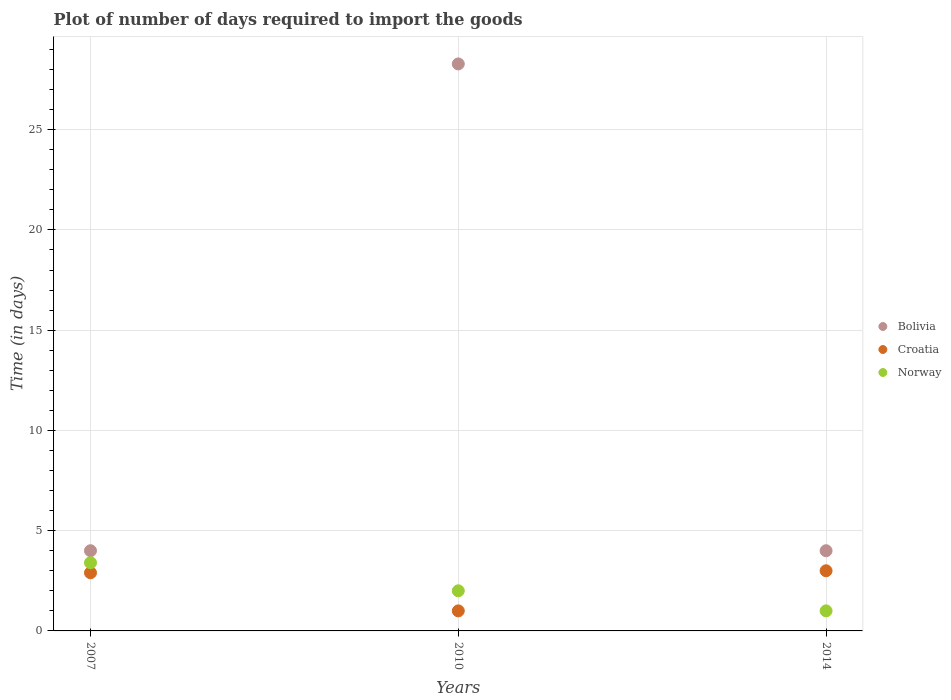How many different coloured dotlines are there?
Offer a terse response. 3. Is the number of dotlines equal to the number of legend labels?
Give a very brief answer. Yes. What is the time required to import goods in Croatia in 2007?
Give a very brief answer. 2.9. Across all years, what is the maximum time required to import goods in Bolivia?
Keep it short and to the point. 28.28. Across all years, what is the minimum time required to import goods in Norway?
Your answer should be compact. 1. What is the difference between the time required to import goods in Norway in 2010 and that in 2014?
Offer a terse response. 1. What is the average time required to import goods in Croatia per year?
Your response must be concise. 2.3. In the year 2014, what is the difference between the time required to import goods in Croatia and time required to import goods in Norway?
Your answer should be compact. 2. In how many years, is the time required to import goods in Bolivia greater than 22 days?
Your answer should be compact. 1. What is the ratio of the time required to import goods in Bolivia in 2007 to that in 2014?
Your answer should be very brief. 1. Is the difference between the time required to import goods in Croatia in 2007 and 2014 greater than the difference between the time required to import goods in Norway in 2007 and 2014?
Ensure brevity in your answer.  No. What is the difference between the highest and the second highest time required to import goods in Bolivia?
Your response must be concise. 24.28. What is the difference between the highest and the lowest time required to import goods in Bolivia?
Give a very brief answer. 24.28. Is it the case that in every year, the sum of the time required to import goods in Norway and time required to import goods in Croatia  is greater than the time required to import goods in Bolivia?
Offer a terse response. No. Does the time required to import goods in Bolivia monotonically increase over the years?
Your answer should be compact. No. Is the time required to import goods in Croatia strictly less than the time required to import goods in Norway over the years?
Offer a terse response. No. How many dotlines are there?
Your answer should be compact. 3. What is the difference between two consecutive major ticks on the Y-axis?
Offer a terse response. 5. Are the values on the major ticks of Y-axis written in scientific E-notation?
Provide a short and direct response. No. Does the graph contain any zero values?
Make the answer very short. No. Does the graph contain grids?
Your response must be concise. Yes. Where does the legend appear in the graph?
Your answer should be very brief. Center right. How are the legend labels stacked?
Your response must be concise. Vertical. What is the title of the graph?
Provide a short and direct response. Plot of number of days required to import the goods. What is the label or title of the X-axis?
Provide a succinct answer. Years. What is the label or title of the Y-axis?
Provide a short and direct response. Time (in days). What is the Time (in days) of Croatia in 2007?
Provide a succinct answer. 2.9. What is the Time (in days) of Norway in 2007?
Your answer should be compact. 3.4. What is the Time (in days) of Bolivia in 2010?
Give a very brief answer. 28.28. What is the Time (in days) of Croatia in 2010?
Offer a terse response. 1. What is the Time (in days) of Bolivia in 2014?
Offer a terse response. 4. What is the Time (in days) of Croatia in 2014?
Ensure brevity in your answer.  3. What is the Time (in days) of Norway in 2014?
Offer a very short reply. 1. Across all years, what is the maximum Time (in days) in Bolivia?
Make the answer very short. 28.28. Across all years, what is the maximum Time (in days) of Croatia?
Offer a very short reply. 3. Across all years, what is the maximum Time (in days) of Norway?
Provide a short and direct response. 3.4. Across all years, what is the minimum Time (in days) of Norway?
Your answer should be very brief. 1. What is the total Time (in days) in Bolivia in the graph?
Your answer should be compact. 36.28. What is the difference between the Time (in days) of Bolivia in 2007 and that in 2010?
Keep it short and to the point. -24.28. What is the difference between the Time (in days) in Norway in 2007 and that in 2010?
Your response must be concise. 1.4. What is the difference between the Time (in days) of Croatia in 2007 and that in 2014?
Your answer should be compact. -0.1. What is the difference between the Time (in days) of Norway in 2007 and that in 2014?
Offer a terse response. 2.4. What is the difference between the Time (in days) of Bolivia in 2010 and that in 2014?
Your answer should be very brief. 24.28. What is the difference between the Time (in days) of Bolivia in 2007 and the Time (in days) of Croatia in 2014?
Offer a very short reply. 1. What is the difference between the Time (in days) in Croatia in 2007 and the Time (in days) in Norway in 2014?
Offer a terse response. 1.9. What is the difference between the Time (in days) in Bolivia in 2010 and the Time (in days) in Croatia in 2014?
Provide a short and direct response. 25.28. What is the difference between the Time (in days) of Bolivia in 2010 and the Time (in days) of Norway in 2014?
Offer a very short reply. 27.28. What is the average Time (in days) of Bolivia per year?
Your answer should be compact. 12.09. What is the average Time (in days) of Norway per year?
Your response must be concise. 2.13. In the year 2007, what is the difference between the Time (in days) of Bolivia and Time (in days) of Norway?
Offer a terse response. 0.6. In the year 2010, what is the difference between the Time (in days) in Bolivia and Time (in days) in Croatia?
Keep it short and to the point. 27.28. In the year 2010, what is the difference between the Time (in days) of Bolivia and Time (in days) of Norway?
Offer a terse response. 26.28. In the year 2010, what is the difference between the Time (in days) of Croatia and Time (in days) of Norway?
Provide a succinct answer. -1. In the year 2014, what is the difference between the Time (in days) in Bolivia and Time (in days) in Norway?
Give a very brief answer. 3. What is the ratio of the Time (in days) of Bolivia in 2007 to that in 2010?
Provide a short and direct response. 0.14. What is the ratio of the Time (in days) of Norway in 2007 to that in 2010?
Give a very brief answer. 1.7. What is the ratio of the Time (in days) in Croatia in 2007 to that in 2014?
Keep it short and to the point. 0.97. What is the ratio of the Time (in days) of Norway in 2007 to that in 2014?
Offer a terse response. 3.4. What is the ratio of the Time (in days) of Bolivia in 2010 to that in 2014?
Provide a succinct answer. 7.07. What is the ratio of the Time (in days) in Norway in 2010 to that in 2014?
Ensure brevity in your answer.  2. What is the difference between the highest and the second highest Time (in days) of Bolivia?
Your response must be concise. 24.28. What is the difference between the highest and the second highest Time (in days) of Norway?
Offer a terse response. 1.4. What is the difference between the highest and the lowest Time (in days) in Bolivia?
Make the answer very short. 24.28. 